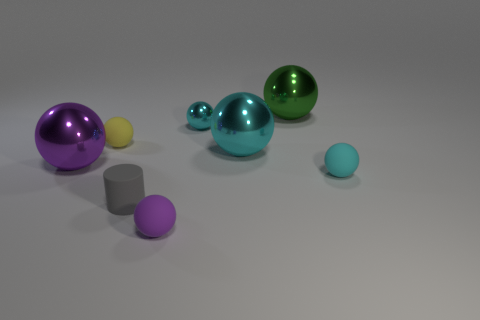Is there any other thing that has the same color as the rubber cylinder? While the image shows various objects, none of them have an identical color to the rubber cylinder. Each object has its own distinct hue, varying in shades and tones. 